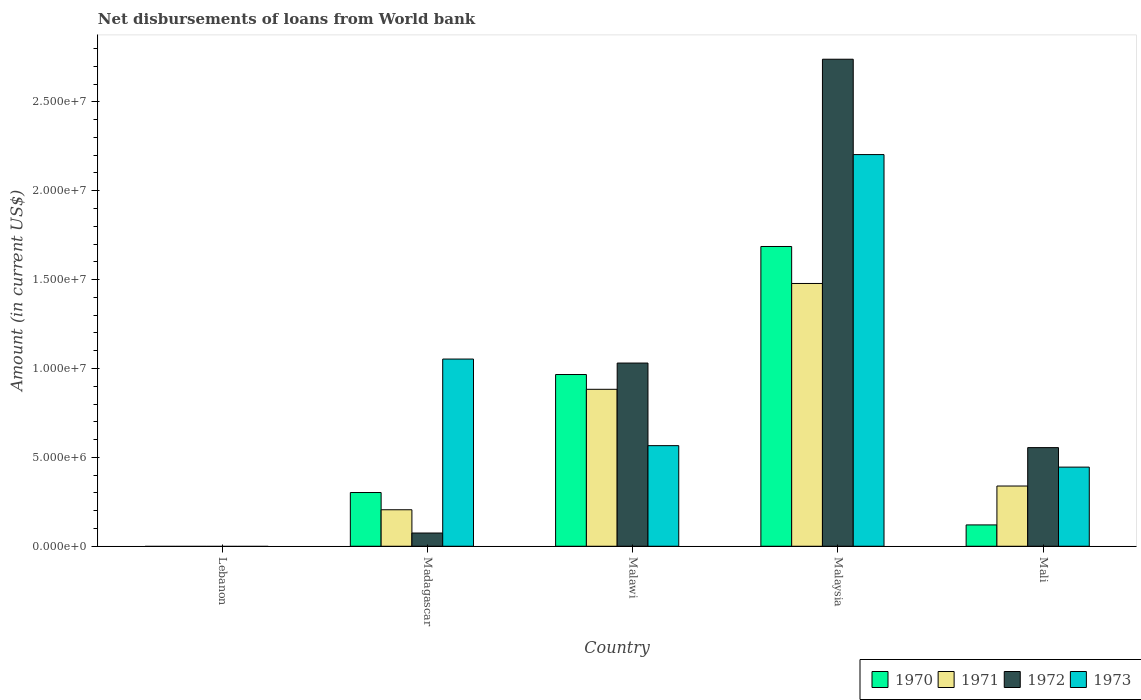Are the number of bars per tick equal to the number of legend labels?
Ensure brevity in your answer.  No. Are the number of bars on each tick of the X-axis equal?
Provide a short and direct response. No. How many bars are there on the 1st tick from the left?
Keep it short and to the point. 0. What is the label of the 2nd group of bars from the left?
Offer a terse response. Madagascar. In how many cases, is the number of bars for a given country not equal to the number of legend labels?
Make the answer very short. 1. What is the amount of loan disbursed from World Bank in 1971 in Madagascar?
Provide a succinct answer. 2.05e+06. Across all countries, what is the maximum amount of loan disbursed from World Bank in 1971?
Your answer should be compact. 1.48e+07. In which country was the amount of loan disbursed from World Bank in 1972 maximum?
Keep it short and to the point. Malaysia. What is the total amount of loan disbursed from World Bank in 1970 in the graph?
Provide a short and direct response. 3.07e+07. What is the difference between the amount of loan disbursed from World Bank in 1970 in Malawi and that in Mali?
Provide a short and direct response. 8.46e+06. What is the difference between the amount of loan disbursed from World Bank in 1970 in Malawi and the amount of loan disbursed from World Bank in 1972 in Mali?
Make the answer very short. 4.11e+06. What is the average amount of loan disbursed from World Bank in 1972 per country?
Provide a short and direct response. 8.80e+06. What is the difference between the amount of loan disbursed from World Bank of/in 1973 and amount of loan disbursed from World Bank of/in 1972 in Madagascar?
Offer a terse response. 9.79e+06. In how many countries, is the amount of loan disbursed from World Bank in 1973 greater than 20000000 US$?
Ensure brevity in your answer.  1. What is the ratio of the amount of loan disbursed from World Bank in 1972 in Malawi to that in Mali?
Your response must be concise. 1.86. Is the amount of loan disbursed from World Bank in 1973 in Madagascar less than that in Malawi?
Keep it short and to the point. No. Is the difference between the amount of loan disbursed from World Bank in 1973 in Malawi and Mali greater than the difference between the amount of loan disbursed from World Bank in 1972 in Malawi and Mali?
Provide a short and direct response. No. What is the difference between the highest and the second highest amount of loan disbursed from World Bank in 1973?
Keep it short and to the point. 1.64e+07. What is the difference between the highest and the lowest amount of loan disbursed from World Bank in 1970?
Offer a very short reply. 1.69e+07. In how many countries, is the amount of loan disbursed from World Bank in 1970 greater than the average amount of loan disbursed from World Bank in 1970 taken over all countries?
Provide a short and direct response. 2. Is the sum of the amount of loan disbursed from World Bank in 1970 in Madagascar and Malawi greater than the maximum amount of loan disbursed from World Bank in 1973 across all countries?
Give a very brief answer. No. How many bars are there?
Your answer should be very brief. 16. What is the difference between two consecutive major ticks on the Y-axis?
Your response must be concise. 5.00e+06. Does the graph contain grids?
Provide a short and direct response. No. Where does the legend appear in the graph?
Your answer should be very brief. Bottom right. How are the legend labels stacked?
Give a very brief answer. Horizontal. What is the title of the graph?
Your answer should be very brief. Net disbursements of loans from World bank. Does "1981" appear as one of the legend labels in the graph?
Your response must be concise. No. What is the Amount (in current US$) in 1970 in Lebanon?
Your answer should be very brief. 0. What is the Amount (in current US$) of 1971 in Lebanon?
Make the answer very short. 0. What is the Amount (in current US$) of 1973 in Lebanon?
Ensure brevity in your answer.  0. What is the Amount (in current US$) in 1970 in Madagascar?
Provide a short and direct response. 3.02e+06. What is the Amount (in current US$) of 1971 in Madagascar?
Give a very brief answer. 2.05e+06. What is the Amount (in current US$) in 1972 in Madagascar?
Ensure brevity in your answer.  7.44e+05. What is the Amount (in current US$) of 1973 in Madagascar?
Offer a very short reply. 1.05e+07. What is the Amount (in current US$) in 1970 in Malawi?
Offer a terse response. 9.66e+06. What is the Amount (in current US$) in 1971 in Malawi?
Ensure brevity in your answer.  8.83e+06. What is the Amount (in current US$) in 1972 in Malawi?
Provide a succinct answer. 1.03e+07. What is the Amount (in current US$) of 1973 in Malawi?
Your response must be concise. 5.66e+06. What is the Amount (in current US$) of 1970 in Malaysia?
Your answer should be very brief. 1.69e+07. What is the Amount (in current US$) in 1971 in Malaysia?
Provide a succinct answer. 1.48e+07. What is the Amount (in current US$) of 1972 in Malaysia?
Provide a succinct answer. 2.74e+07. What is the Amount (in current US$) in 1973 in Malaysia?
Offer a terse response. 2.20e+07. What is the Amount (in current US$) of 1970 in Mali?
Keep it short and to the point. 1.20e+06. What is the Amount (in current US$) of 1971 in Mali?
Give a very brief answer. 3.39e+06. What is the Amount (in current US$) of 1972 in Mali?
Provide a short and direct response. 5.55e+06. What is the Amount (in current US$) of 1973 in Mali?
Your answer should be compact. 4.45e+06. Across all countries, what is the maximum Amount (in current US$) in 1970?
Your answer should be very brief. 1.69e+07. Across all countries, what is the maximum Amount (in current US$) of 1971?
Provide a short and direct response. 1.48e+07. Across all countries, what is the maximum Amount (in current US$) in 1972?
Offer a very short reply. 2.74e+07. Across all countries, what is the maximum Amount (in current US$) of 1973?
Keep it short and to the point. 2.20e+07. Across all countries, what is the minimum Amount (in current US$) in 1971?
Give a very brief answer. 0. Across all countries, what is the minimum Amount (in current US$) of 1973?
Provide a succinct answer. 0. What is the total Amount (in current US$) of 1970 in the graph?
Make the answer very short. 3.07e+07. What is the total Amount (in current US$) in 1971 in the graph?
Your response must be concise. 2.91e+07. What is the total Amount (in current US$) in 1972 in the graph?
Your answer should be compact. 4.40e+07. What is the total Amount (in current US$) of 1973 in the graph?
Give a very brief answer. 4.27e+07. What is the difference between the Amount (in current US$) in 1970 in Madagascar and that in Malawi?
Give a very brief answer. -6.64e+06. What is the difference between the Amount (in current US$) in 1971 in Madagascar and that in Malawi?
Make the answer very short. -6.78e+06. What is the difference between the Amount (in current US$) in 1972 in Madagascar and that in Malawi?
Provide a succinct answer. -9.56e+06. What is the difference between the Amount (in current US$) of 1973 in Madagascar and that in Malawi?
Provide a succinct answer. 4.87e+06. What is the difference between the Amount (in current US$) in 1970 in Madagascar and that in Malaysia?
Offer a terse response. -1.38e+07. What is the difference between the Amount (in current US$) of 1971 in Madagascar and that in Malaysia?
Your answer should be compact. -1.27e+07. What is the difference between the Amount (in current US$) in 1972 in Madagascar and that in Malaysia?
Give a very brief answer. -2.67e+07. What is the difference between the Amount (in current US$) of 1973 in Madagascar and that in Malaysia?
Provide a short and direct response. -1.15e+07. What is the difference between the Amount (in current US$) in 1970 in Madagascar and that in Mali?
Make the answer very short. 1.82e+06. What is the difference between the Amount (in current US$) in 1971 in Madagascar and that in Mali?
Your response must be concise. -1.34e+06. What is the difference between the Amount (in current US$) of 1972 in Madagascar and that in Mali?
Offer a very short reply. -4.80e+06. What is the difference between the Amount (in current US$) of 1973 in Madagascar and that in Mali?
Ensure brevity in your answer.  6.08e+06. What is the difference between the Amount (in current US$) of 1970 in Malawi and that in Malaysia?
Provide a short and direct response. -7.20e+06. What is the difference between the Amount (in current US$) of 1971 in Malawi and that in Malaysia?
Provide a succinct answer. -5.95e+06. What is the difference between the Amount (in current US$) of 1972 in Malawi and that in Malaysia?
Keep it short and to the point. -1.71e+07. What is the difference between the Amount (in current US$) of 1973 in Malawi and that in Malaysia?
Your response must be concise. -1.64e+07. What is the difference between the Amount (in current US$) in 1970 in Malawi and that in Mali?
Provide a short and direct response. 8.46e+06. What is the difference between the Amount (in current US$) of 1971 in Malawi and that in Mali?
Ensure brevity in your answer.  5.44e+06. What is the difference between the Amount (in current US$) in 1972 in Malawi and that in Mali?
Offer a very short reply. 4.76e+06. What is the difference between the Amount (in current US$) in 1973 in Malawi and that in Mali?
Offer a very short reply. 1.21e+06. What is the difference between the Amount (in current US$) of 1970 in Malaysia and that in Mali?
Provide a short and direct response. 1.57e+07. What is the difference between the Amount (in current US$) in 1971 in Malaysia and that in Mali?
Your response must be concise. 1.14e+07. What is the difference between the Amount (in current US$) of 1972 in Malaysia and that in Mali?
Offer a very short reply. 2.19e+07. What is the difference between the Amount (in current US$) of 1973 in Malaysia and that in Mali?
Provide a succinct answer. 1.76e+07. What is the difference between the Amount (in current US$) in 1970 in Madagascar and the Amount (in current US$) in 1971 in Malawi?
Keep it short and to the point. -5.81e+06. What is the difference between the Amount (in current US$) in 1970 in Madagascar and the Amount (in current US$) in 1972 in Malawi?
Keep it short and to the point. -7.28e+06. What is the difference between the Amount (in current US$) of 1970 in Madagascar and the Amount (in current US$) of 1973 in Malawi?
Ensure brevity in your answer.  -2.64e+06. What is the difference between the Amount (in current US$) of 1971 in Madagascar and the Amount (in current US$) of 1972 in Malawi?
Keep it short and to the point. -8.25e+06. What is the difference between the Amount (in current US$) in 1971 in Madagascar and the Amount (in current US$) in 1973 in Malawi?
Provide a short and direct response. -3.61e+06. What is the difference between the Amount (in current US$) in 1972 in Madagascar and the Amount (in current US$) in 1973 in Malawi?
Offer a very short reply. -4.92e+06. What is the difference between the Amount (in current US$) of 1970 in Madagascar and the Amount (in current US$) of 1971 in Malaysia?
Offer a terse response. -1.18e+07. What is the difference between the Amount (in current US$) in 1970 in Madagascar and the Amount (in current US$) in 1972 in Malaysia?
Your response must be concise. -2.44e+07. What is the difference between the Amount (in current US$) in 1970 in Madagascar and the Amount (in current US$) in 1973 in Malaysia?
Offer a very short reply. -1.90e+07. What is the difference between the Amount (in current US$) in 1971 in Madagascar and the Amount (in current US$) in 1972 in Malaysia?
Your answer should be very brief. -2.53e+07. What is the difference between the Amount (in current US$) in 1971 in Madagascar and the Amount (in current US$) in 1973 in Malaysia?
Your answer should be compact. -2.00e+07. What is the difference between the Amount (in current US$) of 1972 in Madagascar and the Amount (in current US$) of 1973 in Malaysia?
Provide a short and direct response. -2.13e+07. What is the difference between the Amount (in current US$) in 1970 in Madagascar and the Amount (in current US$) in 1971 in Mali?
Your answer should be very brief. -3.65e+05. What is the difference between the Amount (in current US$) in 1970 in Madagascar and the Amount (in current US$) in 1972 in Mali?
Provide a succinct answer. -2.53e+06. What is the difference between the Amount (in current US$) of 1970 in Madagascar and the Amount (in current US$) of 1973 in Mali?
Your answer should be very brief. -1.43e+06. What is the difference between the Amount (in current US$) of 1971 in Madagascar and the Amount (in current US$) of 1972 in Mali?
Your answer should be very brief. -3.50e+06. What is the difference between the Amount (in current US$) of 1971 in Madagascar and the Amount (in current US$) of 1973 in Mali?
Keep it short and to the point. -2.40e+06. What is the difference between the Amount (in current US$) of 1972 in Madagascar and the Amount (in current US$) of 1973 in Mali?
Your answer should be very brief. -3.71e+06. What is the difference between the Amount (in current US$) of 1970 in Malawi and the Amount (in current US$) of 1971 in Malaysia?
Offer a terse response. -5.12e+06. What is the difference between the Amount (in current US$) of 1970 in Malawi and the Amount (in current US$) of 1972 in Malaysia?
Give a very brief answer. -1.77e+07. What is the difference between the Amount (in current US$) in 1970 in Malawi and the Amount (in current US$) in 1973 in Malaysia?
Your answer should be very brief. -1.24e+07. What is the difference between the Amount (in current US$) in 1971 in Malawi and the Amount (in current US$) in 1972 in Malaysia?
Your answer should be compact. -1.86e+07. What is the difference between the Amount (in current US$) of 1971 in Malawi and the Amount (in current US$) of 1973 in Malaysia?
Your answer should be compact. -1.32e+07. What is the difference between the Amount (in current US$) in 1972 in Malawi and the Amount (in current US$) in 1973 in Malaysia?
Ensure brevity in your answer.  -1.17e+07. What is the difference between the Amount (in current US$) in 1970 in Malawi and the Amount (in current US$) in 1971 in Mali?
Keep it short and to the point. 6.27e+06. What is the difference between the Amount (in current US$) of 1970 in Malawi and the Amount (in current US$) of 1972 in Mali?
Make the answer very short. 4.11e+06. What is the difference between the Amount (in current US$) in 1970 in Malawi and the Amount (in current US$) in 1973 in Mali?
Keep it short and to the point. 5.21e+06. What is the difference between the Amount (in current US$) of 1971 in Malawi and the Amount (in current US$) of 1972 in Mali?
Provide a short and direct response. 3.28e+06. What is the difference between the Amount (in current US$) of 1971 in Malawi and the Amount (in current US$) of 1973 in Mali?
Ensure brevity in your answer.  4.38e+06. What is the difference between the Amount (in current US$) in 1972 in Malawi and the Amount (in current US$) in 1973 in Mali?
Provide a short and direct response. 5.86e+06. What is the difference between the Amount (in current US$) in 1970 in Malaysia and the Amount (in current US$) in 1971 in Mali?
Offer a very short reply. 1.35e+07. What is the difference between the Amount (in current US$) of 1970 in Malaysia and the Amount (in current US$) of 1972 in Mali?
Keep it short and to the point. 1.13e+07. What is the difference between the Amount (in current US$) in 1970 in Malaysia and the Amount (in current US$) in 1973 in Mali?
Your answer should be compact. 1.24e+07. What is the difference between the Amount (in current US$) of 1971 in Malaysia and the Amount (in current US$) of 1972 in Mali?
Keep it short and to the point. 9.24e+06. What is the difference between the Amount (in current US$) of 1971 in Malaysia and the Amount (in current US$) of 1973 in Mali?
Your answer should be very brief. 1.03e+07. What is the difference between the Amount (in current US$) of 1972 in Malaysia and the Amount (in current US$) of 1973 in Mali?
Offer a very short reply. 2.29e+07. What is the average Amount (in current US$) in 1970 per country?
Offer a terse response. 6.15e+06. What is the average Amount (in current US$) in 1971 per country?
Your response must be concise. 5.81e+06. What is the average Amount (in current US$) of 1972 per country?
Provide a succinct answer. 8.80e+06. What is the average Amount (in current US$) in 1973 per country?
Keep it short and to the point. 8.54e+06. What is the difference between the Amount (in current US$) of 1970 and Amount (in current US$) of 1971 in Madagascar?
Your answer should be compact. 9.70e+05. What is the difference between the Amount (in current US$) in 1970 and Amount (in current US$) in 1972 in Madagascar?
Offer a terse response. 2.28e+06. What is the difference between the Amount (in current US$) in 1970 and Amount (in current US$) in 1973 in Madagascar?
Your answer should be very brief. -7.51e+06. What is the difference between the Amount (in current US$) in 1971 and Amount (in current US$) in 1972 in Madagascar?
Keep it short and to the point. 1.31e+06. What is the difference between the Amount (in current US$) in 1971 and Amount (in current US$) in 1973 in Madagascar?
Make the answer very short. -8.48e+06. What is the difference between the Amount (in current US$) of 1972 and Amount (in current US$) of 1973 in Madagascar?
Offer a terse response. -9.79e+06. What is the difference between the Amount (in current US$) of 1970 and Amount (in current US$) of 1971 in Malawi?
Your response must be concise. 8.31e+05. What is the difference between the Amount (in current US$) in 1970 and Amount (in current US$) in 1972 in Malawi?
Provide a short and direct response. -6.46e+05. What is the difference between the Amount (in current US$) in 1970 and Amount (in current US$) in 1973 in Malawi?
Make the answer very short. 4.00e+06. What is the difference between the Amount (in current US$) of 1971 and Amount (in current US$) of 1972 in Malawi?
Provide a short and direct response. -1.48e+06. What is the difference between the Amount (in current US$) of 1971 and Amount (in current US$) of 1973 in Malawi?
Provide a short and direct response. 3.17e+06. What is the difference between the Amount (in current US$) of 1972 and Amount (in current US$) of 1973 in Malawi?
Make the answer very short. 4.65e+06. What is the difference between the Amount (in current US$) in 1970 and Amount (in current US$) in 1971 in Malaysia?
Offer a very short reply. 2.08e+06. What is the difference between the Amount (in current US$) in 1970 and Amount (in current US$) in 1972 in Malaysia?
Give a very brief answer. -1.05e+07. What is the difference between the Amount (in current US$) in 1970 and Amount (in current US$) in 1973 in Malaysia?
Give a very brief answer. -5.17e+06. What is the difference between the Amount (in current US$) of 1971 and Amount (in current US$) of 1972 in Malaysia?
Ensure brevity in your answer.  -1.26e+07. What is the difference between the Amount (in current US$) in 1971 and Amount (in current US$) in 1973 in Malaysia?
Your answer should be very brief. -7.25e+06. What is the difference between the Amount (in current US$) of 1972 and Amount (in current US$) of 1973 in Malaysia?
Give a very brief answer. 5.36e+06. What is the difference between the Amount (in current US$) of 1970 and Amount (in current US$) of 1971 in Mali?
Give a very brief answer. -2.19e+06. What is the difference between the Amount (in current US$) in 1970 and Amount (in current US$) in 1972 in Mali?
Offer a very short reply. -4.35e+06. What is the difference between the Amount (in current US$) of 1970 and Amount (in current US$) of 1973 in Mali?
Ensure brevity in your answer.  -3.25e+06. What is the difference between the Amount (in current US$) in 1971 and Amount (in current US$) in 1972 in Mali?
Your response must be concise. -2.16e+06. What is the difference between the Amount (in current US$) in 1971 and Amount (in current US$) in 1973 in Mali?
Give a very brief answer. -1.06e+06. What is the difference between the Amount (in current US$) of 1972 and Amount (in current US$) of 1973 in Mali?
Offer a very short reply. 1.10e+06. What is the ratio of the Amount (in current US$) of 1970 in Madagascar to that in Malawi?
Provide a succinct answer. 0.31. What is the ratio of the Amount (in current US$) of 1971 in Madagascar to that in Malawi?
Offer a terse response. 0.23. What is the ratio of the Amount (in current US$) of 1972 in Madagascar to that in Malawi?
Offer a terse response. 0.07. What is the ratio of the Amount (in current US$) in 1973 in Madagascar to that in Malawi?
Keep it short and to the point. 1.86. What is the ratio of the Amount (in current US$) of 1970 in Madagascar to that in Malaysia?
Your answer should be very brief. 0.18. What is the ratio of the Amount (in current US$) in 1971 in Madagascar to that in Malaysia?
Give a very brief answer. 0.14. What is the ratio of the Amount (in current US$) in 1972 in Madagascar to that in Malaysia?
Give a very brief answer. 0.03. What is the ratio of the Amount (in current US$) of 1973 in Madagascar to that in Malaysia?
Offer a very short reply. 0.48. What is the ratio of the Amount (in current US$) of 1970 in Madagascar to that in Mali?
Give a very brief answer. 2.52. What is the ratio of the Amount (in current US$) of 1971 in Madagascar to that in Mali?
Provide a short and direct response. 0.61. What is the ratio of the Amount (in current US$) of 1972 in Madagascar to that in Mali?
Offer a terse response. 0.13. What is the ratio of the Amount (in current US$) in 1973 in Madagascar to that in Mali?
Ensure brevity in your answer.  2.37. What is the ratio of the Amount (in current US$) in 1970 in Malawi to that in Malaysia?
Offer a terse response. 0.57. What is the ratio of the Amount (in current US$) in 1971 in Malawi to that in Malaysia?
Your answer should be very brief. 0.6. What is the ratio of the Amount (in current US$) in 1972 in Malawi to that in Malaysia?
Give a very brief answer. 0.38. What is the ratio of the Amount (in current US$) of 1973 in Malawi to that in Malaysia?
Provide a succinct answer. 0.26. What is the ratio of the Amount (in current US$) in 1970 in Malawi to that in Mali?
Your response must be concise. 8.05. What is the ratio of the Amount (in current US$) in 1971 in Malawi to that in Mali?
Provide a short and direct response. 2.61. What is the ratio of the Amount (in current US$) of 1972 in Malawi to that in Mali?
Your answer should be very brief. 1.86. What is the ratio of the Amount (in current US$) in 1973 in Malawi to that in Mali?
Give a very brief answer. 1.27. What is the ratio of the Amount (in current US$) in 1970 in Malaysia to that in Mali?
Keep it short and to the point. 14.05. What is the ratio of the Amount (in current US$) in 1971 in Malaysia to that in Mali?
Ensure brevity in your answer.  4.36. What is the ratio of the Amount (in current US$) of 1972 in Malaysia to that in Mali?
Provide a short and direct response. 4.94. What is the ratio of the Amount (in current US$) of 1973 in Malaysia to that in Mali?
Your answer should be compact. 4.95. What is the difference between the highest and the second highest Amount (in current US$) of 1970?
Keep it short and to the point. 7.20e+06. What is the difference between the highest and the second highest Amount (in current US$) of 1971?
Give a very brief answer. 5.95e+06. What is the difference between the highest and the second highest Amount (in current US$) of 1972?
Give a very brief answer. 1.71e+07. What is the difference between the highest and the second highest Amount (in current US$) in 1973?
Your answer should be very brief. 1.15e+07. What is the difference between the highest and the lowest Amount (in current US$) of 1970?
Make the answer very short. 1.69e+07. What is the difference between the highest and the lowest Amount (in current US$) in 1971?
Ensure brevity in your answer.  1.48e+07. What is the difference between the highest and the lowest Amount (in current US$) in 1972?
Give a very brief answer. 2.74e+07. What is the difference between the highest and the lowest Amount (in current US$) of 1973?
Offer a very short reply. 2.20e+07. 